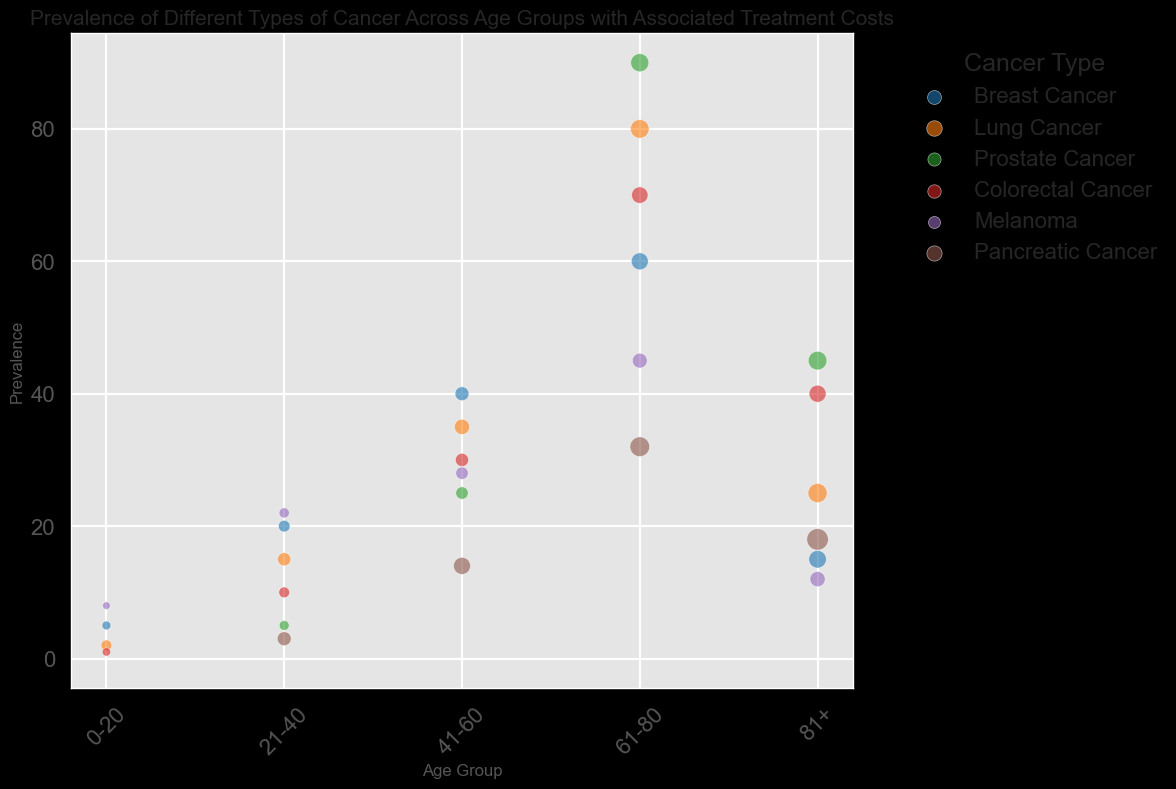What age group has the highest prevalence of Breast Cancer? The age group with the highest prevalence of Breast Cancer can be identified by looking for the largest circle in the section labeled "Breast Cancer". The largest circle appears in the "61-80" age group.
Answer: 61-80 Which cancer type has the highest treatment cost for the 81+ age group? The highest treatment cost for the 81+ age group is indicated by the size of the bubbles in that age group section. "Pancreatic Cancer" has the largest bubble, indicating the highest average treatment cost.
Answer: Pancreatic Cancer For Lung Cancer, what is the difference in prevalence between the 21-40 and 61-80 age groups? To find the difference, identify the prevalence values for each age group in the "Lung Cancer" category. The prevalence for the 21-40 age group is 15, and for the 61-80 age group, it is 80. The difference is 80 - 15.
Answer: 65 Among all the cancers, which one has the smallest bubble for the 0-20 age group? The size of the bubble represents treatment costs. The smallest bubble in the 0-20 age group is seen in "Prostate Cancer" and "Pancreatic Cancer", both of which have no prevalence and thus no treatment cost.
Answer: Prostate Cancer and Pancreatic Cancer Which age group has the highest cumulative prevalence of all cancer types combined? Calculate the total prevalence for each age group by summing the prevalence values for each type of cancer within the same age group. The cumulative prevalence for the 61-80 age group is the highest: Breast Cancer (60) + Lung Cancer (80) + Prostate Cancer (90) + Colorectal Cancer (70) + Melanoma (45) + Pancreatic Cancer (32).
Answer: 61-80 How does the average treatment cost for Breast Cancer in the 41-60 age group compare to that for Colorectal Cancer in the same age group? Compare the sizes of the bubbles within the "41-60" age group for "Breast Cancer" and "Colorectal Cancer". The bubble for Breast Cancer is slightly larger, indicating a higher treatment cost.
Answer: Breast Cancer has a higher treatment cost What is the total prevalence of Melanoma across all age groups? Add the prevalence of Melanoma across all age groups: 0-20 (8) + 21-40 (22) + 41-60 (28) + 61-80 (45) + 81+ (12). The total prevalence is 115.
Answer: 115 In the 61-80 age group, which cancer type has both a high prevalence and a high treatment cost? Look for large bubbles in the "61-80" age group. Both the prevalence and bubble size for "Prostate Cancer" are significant.
Answer: Prostate Cancer What color represents Colorectal Cancer in the plot? Identify the legend that maps cancer types to colors. The color associated with "Colorectal Cancer" is readily visible.
Answer: Red What is the difference in average treatment costs between Melanoma and Pancreatic Cancer in the 81+ age group? Find the treatment costs for Melanoma (60000) and Pancreatic Cancer (120000) in the 81+ age group. The difference is 120000 - 60000.
Answer: 60000 